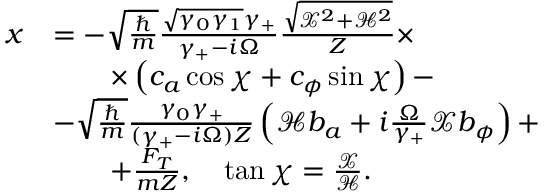<formula> <loc_0><loc_0><loc_500><loc_500>\begin{array} { r l } { x } & { = - \sqrt { \frac { } { m } } \frac { \sqrt { \gamma _ { 0 } \gamma _ { 1 } } \gamma _ { + } } { \gamma _ { + } - i \Omega } \frac { \sqrt { \mathcal { X } ^ { 2 } + \mathcal { H } ^ { 2 } } } { Z } \times } \\ & { \quad \times \left ( c _ { a } \cos \chi + c _ { \phi } \sin \chi \right ) - } \\ & { - \sqrt { \frac { } { m } } \frac { \gamma _ { 0 } \gamma _ { + } } { ( \gamma _ { + } - i \Omega ) Z } \left ( \mathcal { H } b _ { a } + i \frac { \Omega } { \gamma _ { + } } \mathcal { X } b _ { \phi } \right ) + } \\ & { \quad + \frac { F _ { T } } { m Z } , \quad \tan \chi = \frac { \mathcal { X } } { \mathcal { H } } . } \end{array}</formula> 